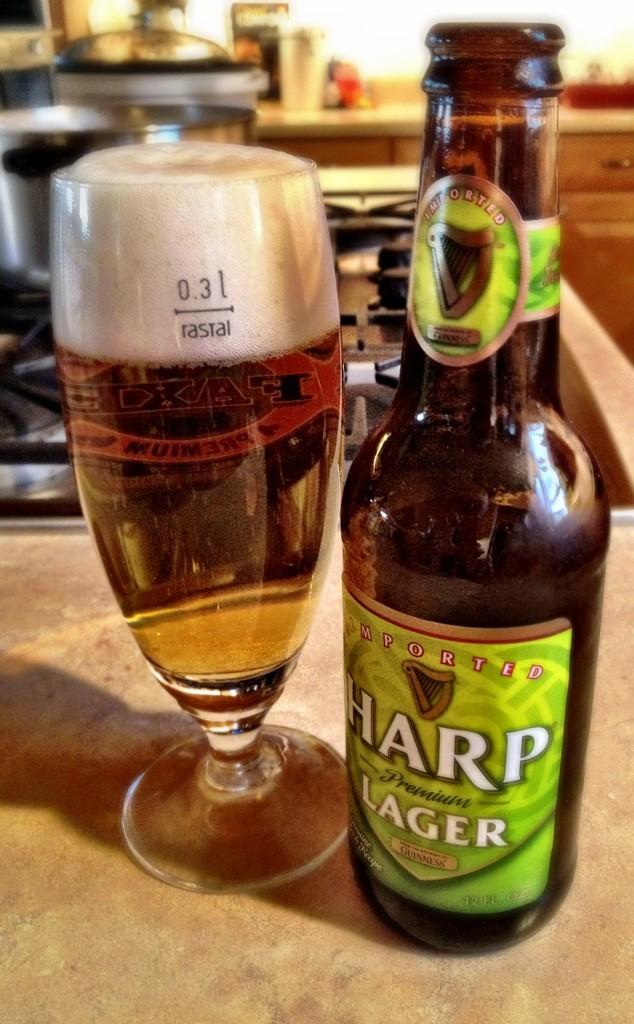<image>
Provide a brief description of the given image. Harp Lager beer bottle with green label next to a cup of beer. 